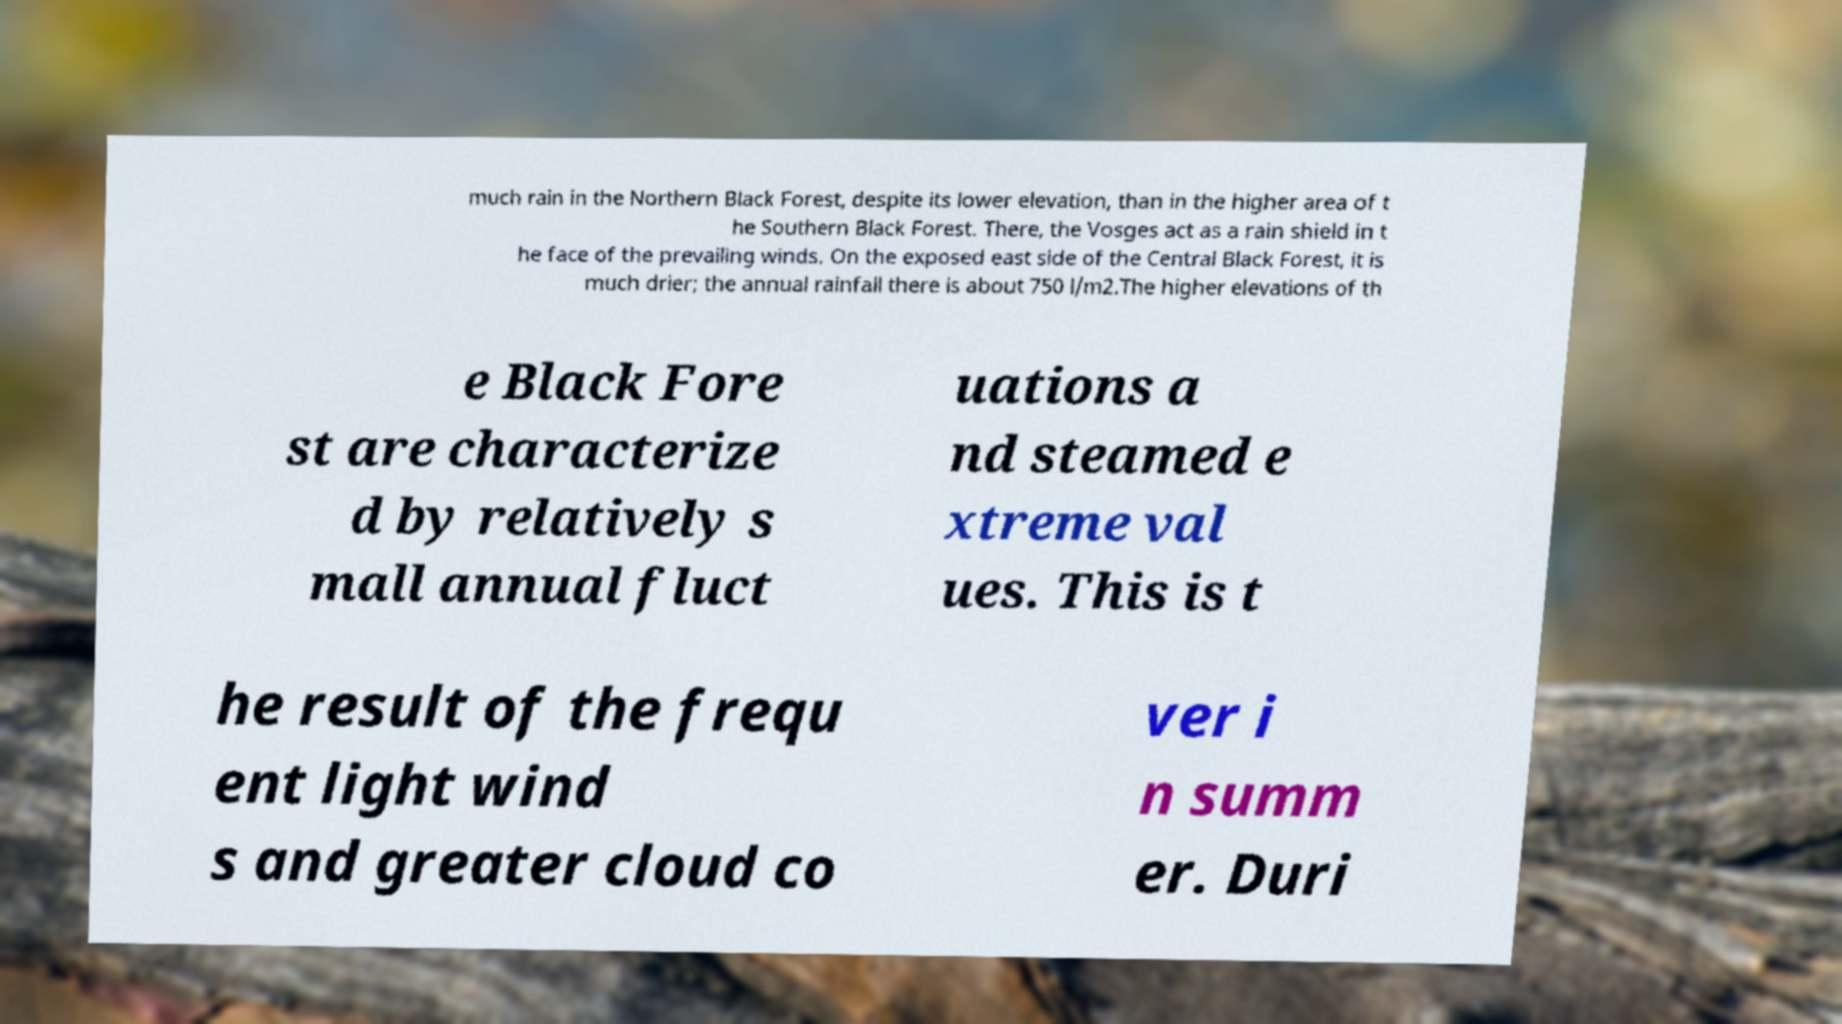Could you extract and type out the text from this image? much rain in the Northern Black Forest, despite its lower elevation, than in the higher area of t he Southern Black Forest. There, the Vosges act as a rain shield in t he face of the prevailing winds. On the exposed east side of the Central Black Forest, it is much drier; the annual rainfall there is about 750 l/m2.The higher elevations of th e Black Fore st are characterize d by relatively s mall annual fluct uations a nd steamed e xtreme val ues. This is t he result of the frequ ent light wind s and greater cloud co ver i n summ er. Duri 